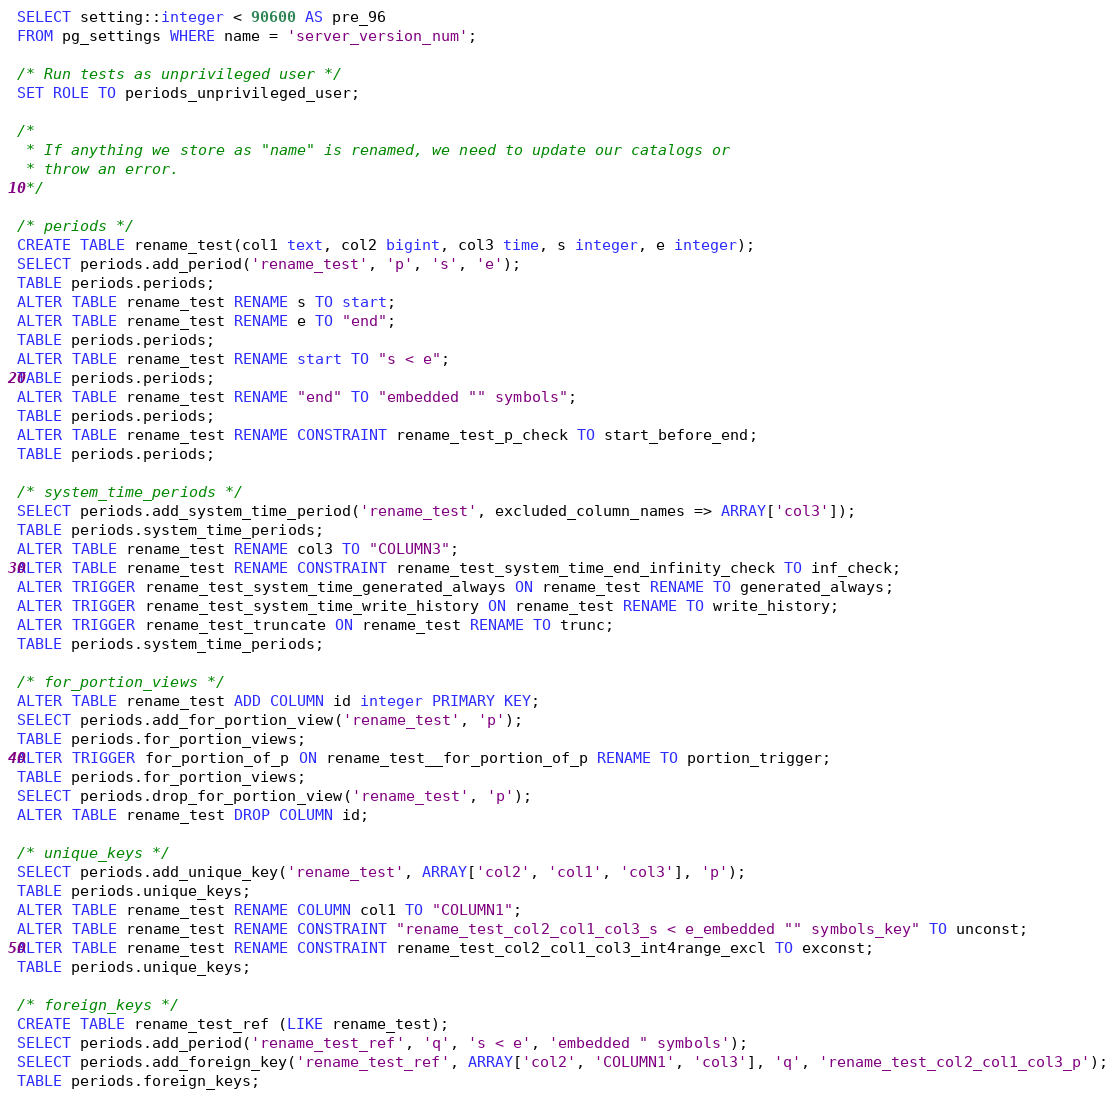Convert code to text. <code><loc_0><loc_0><loc_500><loc_500><_SQL_>SELECT setting::integer < 90600 AS pre_96
FROM pg_settings WHERE name = 'server_version_num';

/* Run tests as unprivileged user */
SET ROLE TO periods_unprivileged_user;

/*
 * If anything we store as "name" is renamed, we need to update our catalogs or
 * throw an error.
 */

/* periods */
CREATE TABLE rename_test(col1 text, col2 bigint, col3 time, s integer, e integer);
SELECT periods.add_period('rename_test', 'p', 's', 'e');
TABLE periods.periods;
ALTER TABLE rename_test RENAME s TO start;
ALTER TABLE rename_test RENAME e TO "end";
TABLE periods.periods;
ALTER TABLE rename_test RENAME start TO "s < e";
TABLE periods.periods;
ALTER TABLE rename_test RENAME "end" TO "embedded "" symbols";
TABLE periods.periods;
ALTER TABLE rename_test RENAME CONSTRAINT rename_test_p_check TO start_before_end;
TABLE periods.periods;

/* system_time_periods */
SELECT periods.add_system_time_period('rename_test', excluded_column_names => ARRAY['col3']);
TABLE periods.system_time_periods;
ALTER TABLE rename_test RENAME col3 TO "COLUMN3";
ALTER TABLE rename_test RENAME CONSTRAINT rename_test_system_time_end_infinity_check TO inf_check;
ALTER TRIGGER rename_test_system_time_generated_always ON rename_test RENAME TO generated_always;
ALTER TRIGGER rename_test_system_time_write_history ON rename_test RENAME TO write_history;
ALTER TRIGGER rename_test_truncate ON rename_test RENAME TO trunc;
TABLE periods.system_time_periods;

/* for_portion_views */
ALTER TABLE rename_test ADD COLUMN id integer PRIMARY KEY;
SELECT periods.add_for_portion_view('rename_test', 'p');
TABLE periods.for_portion_views;
ALTER TRIGGER for_portion_of_p ON rename_test__for_portion_of_p RENAME TO portion_trigger;
TABLE periods.for_portion_views;
SELECT periods.drop_for_portion_view('rename_test', 'p');
ALTER TABLE rename_test DROP COLUMN id;

/* unique_keys */
SELECT periods.add_unique_key('rename_test', ARRAY['col2', 'col1', 'col3'], 'p');
TABLE periods.unique_keys;
ALTER TABLE rename_test RENAME COLUMN col1 TO "COLUMN1";
ALTER TABLE rename_test RENAME CONSTRAINT "rename_test_col2_col1_col3_s < e_embedded "" symbols_key" TO unconst;
ALTER TABLE rename_test RENAME CONSTRAINT rename_test_col2_col1_col3_int4range_excl TO exconst;
TABLE periods.unique_keys;

/* foreign_keys */
CREATE TABLE rename_test_ref (LIKE rename_test);
SELECT periods.add_period('rename_test_ref', 'q', 's < e', 'embedded " symbols');
SELECT periods.add_foreign_key('rename_test_ref', ARRAY['col2', 'COLUMN1', 'col3'], 'q', 'rename_test_col2_col1_col3_p');
TABLE periods.foreign_keys;</code> 